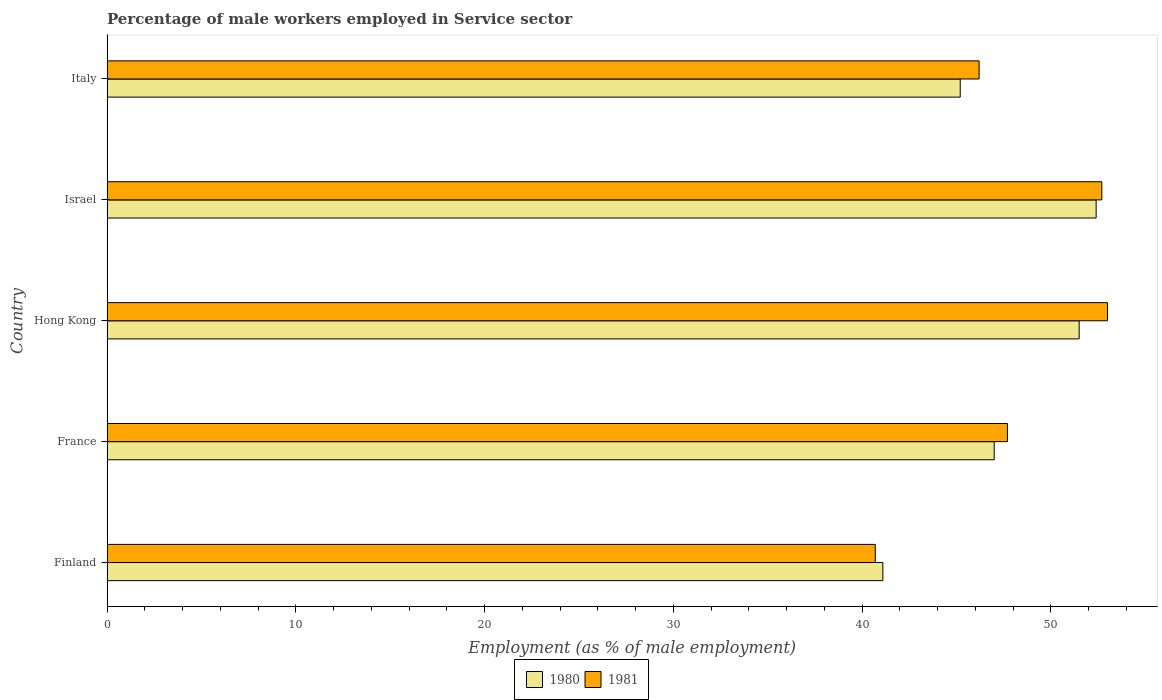Are the number of bars per tick equal to the number of legend labels?
Give a very brief answer. Yes. How many bars are there on the 1st tick from the top?
Provide a short and direct response. 2. In how many cases, is the number of bars for a given country not equal to the number of legend labels?
Provide a short and direct response. 0. What is the percentage of male workers employed in Service sector in 1981 in France?
Keep it short and to the point. 47.7. Across all countries, what is the minimum percentage of male workers employed in Service sector in 1980?
Your answer should be compact. 41.1. What is the total percentage of male workers employed in Service sector in 1980 in the graph?
Provide a succinct answer. 237.2. What is the difference between the percentage of male workers employed in Service sector in 1981 in Finland and that in Italy?
Keep it short and to the point. -5.5. What is the difference between the percentage of male workers employed in Service sector in 1980 in Finland and the percentage of male workers employed in Service sector in 1981 in Italy?
Offer a very short reply. -5.1. What is the average percentage of male workers employed in Service sector in 1980 per country?
Your answer should be compact. 47.44. What is the difference between the percentage of male workers employed in Service sector in 1981 and percentage of male workers employed in Service sector in 1980 in Israel?
Your answer should be compact. 0.3. In how many countries, is the percentage of male workers employed in Service sector in 1981 greater than 40 %?
Offer a terse response. 5. What is the ratio of the percentage of male workers employed in Service sector in 1981 in Finland to that in Italy?
Provide a succinct answer. 0.88. What is the difference between the highest and the second highest percentage of male workers employed in Service sector in 1980?
Ensure brevity in your answer.  0.9. What is the difference between the highest and the lowest percentage of male workers employed in Service sector in 1980?
Keep it short and to the point. 11.3. Is the sum of the percentage of male workers employed in Service sector in 1981 in France and Hong Kong greater than the maximum percentage of male workers employed in Service sector in 1980 across all countries?
Keep it short and to the point. Yes. What does the 1st bar from the bottom in Israel represents?
Offer a very short reply. 1980. How many bars are there?
Make the answer very short. 10. How many countries are there in the graph?
Your answer should be very brief. 5. What is the difference between two consecutive major ticks on the X-axis?
Ensure brevity in your answer.  10. Where does the legend appear in the graph?
Give a very brief answer. Bottom center. How are the legend labels stacked?
Offer a terse response. Horizontal. What is the title of the graph?
Offer a very short reply. Percentage of male workers employed in Service sector. What is the label or title of the X-axis?
Provide a short and direct response. Employment (as % of male employment). What is the label or title of the Y-axis?
Your response must be concise. Country. What is the Employment (as % of male employment) of 1980 in Finland?
Keep it short and to the point. 41.1. What is the Employment (as % of male employment) of 1981 in Finland?
Offer a very short reply. 40.7. What is the Employment (as % of male employment) in 1980 in France?
Give a very brief answer. 47. What is the Employment (as % of male employment) in 1981 in France?
Offer a terse response. 47.7. What is the Employment (as % of male employment) of 1980 in Hong Kong?
Give a very brief answer. 51.5. What is the Employment (as % of male employment) of 1981 in Hong Kong?
Provide a succinct answer. 53. What is the Employment (as % of male employment) in 1980 in Israel?
Offer a terse response. 52.4. What is the Employment (as % of male employment) in 1981 in Israel?
Provide a succinct answer. 52.7. What is the Employment (as % of male employment) in 1980 in Italy?
Offer a terse response. 45.2. What is the Employment (as % of male employment) in 1981 in Italy?
Offer a very short reply. 46.2. Across all countries, what is the maximum Employment (as % of male employment) in 1980?
Your answer should be compact. 52.4. Across all countries, what is the maximum Employment (as % of male employment) of 1981?
Your answer should be very brief. 53. Across all countries, what is the minimum Employment (as % of male employment) of 1980?
Your answer should be very brief. 41.1. Across all countries, what is the minimum Employment (as % of male employment) in 1981?
Ensure brevity in your answer.  40.7. What is the total Employment (as % of male employment) of 1980 in the graph?
Ensure brevity in your answer.  237.2. What is the total Employment (as % of male employment) of 1981 in the graph?
Ensure brevity in your answer.  240.3. What is the difference between the Employment (as % of male employment) in 1980 in Finland and that in Israel?
Provide a short and direct response. -11.3. What is the difference between the Employment (as % of male employment) of 1981 in Finland and that in Italy?
Your response must be concise. -5.5. What is the difference between the Employment (as % of male employment) in 1980 in France and that in Hong Kong?
Provide a short and direct response. -4.5. What is the difference between the Employment (as % of male employment) of 1980 in France and that in Italy?
Make the answer very short. 1.8. What is the difference between the Employment (as % of male employment) in 1981 in Hong Kong and that in Israel?
Give a very brief answer. 0.3. What is the difference between the Employment (as % of male employment) in 1981 in Hong Kong and that in Italy?
Ensure brevity in your answer.  6.8. What is the difference between the Employment (as % of male employment) in 1980 in Israel and that in Italy?
Ensure brevity in your answer.  7.2. What is the difference between the Employment (as % of male employment) of 1981 in Israel and that in Italy?
Make the answer very short. 6.5. What is the difference between the Employment (as % of male employment) in 1980 in Finland and the Employment (as % of male employment) in 1981 in France?
Offer a terse response. -6.6. What is the difference between the Employment (as % of male employment) of 1980 in Finland and the Employment (as % of male employment) of 1981 in Israel?
Your answer should be very brief. -11.6. What is the difference between the Employment (as % of male employment) in 1980 in Finland and the Employment (as % of male employment) in 1981 in Italy?
Ensure brevity in your answer.  -5.1. What is the difference between the Employment (as % of male employment) of 1980 in France and the Employment (as % of male employment) of 1981 in Hong Kong?
Your answer should be very brief. -6. What is the difference between the Employment (as % of male employment) of 1980 in France and the Employment (as % of male employment) of 1981 in Italy?
Keep it short and to the point. 0.8. What is the difference between the Employment (as % of male employment) in 1980 in Hong Kong and the Employment (as % of male employment) in 1981 in Italy?
Provide a succinct answer. 5.3. What is the difference between the Employment (as % of male employment) in 1980 in Israel and the Employment (as % of male employment) in 1981 in Italy?
Ensure brevity in your answer.  6.2. What is the average Employment (as % of male employment) of 1980 per country?
Offer a terse response. 47.44. What is the average Employment (as % of male employment) in 1981 per country?
Provide a succinct answer. 48.06. What is the difference between the Employment (as % of male employment) of 1980 and Employment (as % of male employment) of 1981 in France?
Provide a succinct answer. -0.7. What is the difference between the Employment (as % of male employment) in 1980 and Employment (as % of male employment) in 1981 in Hong Kong?
Provide a short and direct response. -1.5. What is the ratio of the Employment (as % of male employment) in 1980 in Finland to that in France?
Your answer should be compact. 0.87. What is the ratio of the Employment (as % of male employment) of 1981 in Finland to that in France?
Give a very brief answer. 0.85. What is the ratio of the Employment (as % of male employment) in 1980 in Finland to that in Hong Kong?
Make the answer very short. 0.8. What is the ratio of the Employment (as % of male employment) of 1981 in Finland to that in Hong Kong?
Your answer should be compact. 0.77. What is the ratio of the Employment (as % of male employment) of 1980 in Finland to that in Israel?
Ensure brevity in your answer.  0.78. What is the ratio of the Employment (as % of male employment) of 1981 in Finland to that in Israel?
Your answer should be compact. 0.77. What is the ratio of the Employment (as % of male employment) in 1980 in Finland to that in Italy?
Make the answer very short. 0.91. What is the ratio of the Employment (as % of male employment) in 1981 in Finland to that in Italy?
Offer a very short reply. 0.88. What is the ratio of the Employment (as % of male employment) in 1980 in France to that in Hong Kong?
Keep it short and to the point. 0.91. What is the ratio of the Employment (as % of male employment) in 1981 in France to that in Hong Kong?
Your answer should be very brief. 0.9. What is the ratio of the Employment (as % of male employment) in 1980 in France to that in Israel?
Provide a short and direct response. 0.9. What is the ratio of the Employment (as % of male employment) in 1981 in France to that in Israel?
Your answer should be very brief. 0.91. What is the ratio of the Employment (as % of male employment) of 1980 in France to that in Italy?
Provide a short and direct response. 1.04. What is the ratio of the Employment (as % of male employment) of 1981 in France to that in Italy?
Provide a short and direct response. 1.03. What is the ratio of the Employment (as % of male employment) in 1980 in Hong Kong to that in Israel?
Offer a very short reply. 0.98. What is the ratio of the Employment (as % of male employment) of 1980 in Hong Kong to that in Italy?
Your answer should be compact. 1.14. What is the ratio of the Employment (as % of male employment) of 1981 in Hong Kong to that in Italy?
Provide a short and direct response. 1.15. What is the ratio of the Employment (as % of male employment) in 1980 in Israel to that in Italy?
Provide a short and direct response. 1.16. What is the ratio of the Employment (as % of male employment) of 1981 in Israel to that in Italy?
Your answer should be very brief. 1.14. 